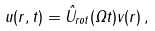<formula> <loc_0><loc_0><loc_500><loc_500>u ( r , t ) = \hat { U } _ { r o t } ( \Omega t ) v ( r ) \, ,</formula> 